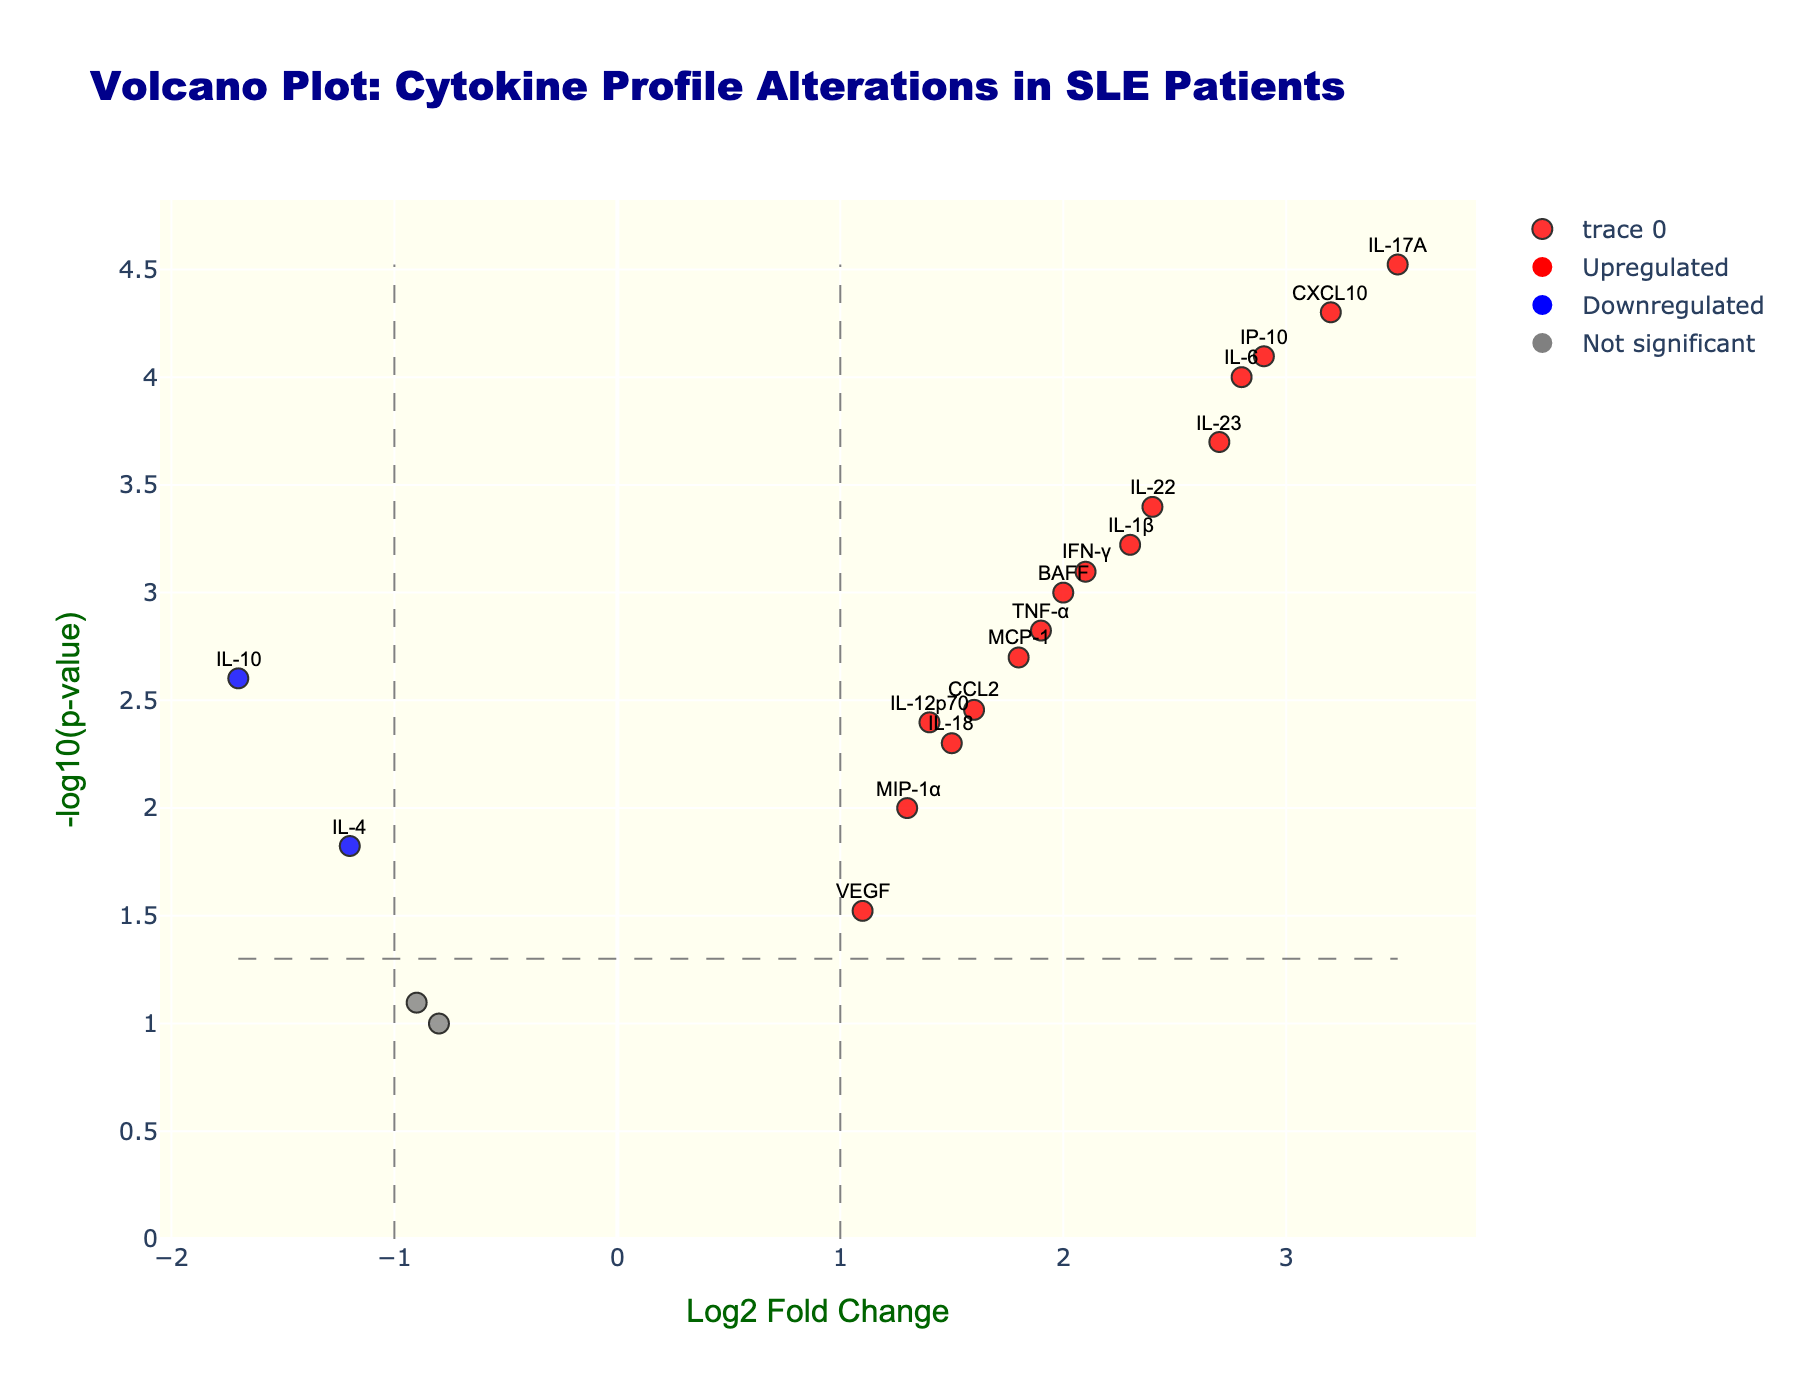How many data points have been plotted in the volcano plot? Count the number of markers plotted on the figure. The plot shows data points for each cytokine, so the number of plotted data points is equal to the number of cytokines in the provided data.
Answer: 19 What is the title of the volcano plot? The title is displayed at the top of the plot and typically summarizes what the plot represents. In this case, it is given in the figure description.
Answer: Volcano Plot: Cytokine Profile Alterations in SLE Patients Which cytokines show significant upregulation in SLE patients? Significant upregulation is indicated by red dots, where Log2FoldChange > 1 and P-value < 0.05. By identifying the red markers in the plot, we can list these cytokines.
Answer: IL-6, IL-17A, IFN-γ, IL-1β, CXCL10, IL-23, BAFF, IP-10, IL-22 Which cytokine shows the highest upregulation and what are its Log2 fold change and p-value? Look for the red marker with the highest Log2 Fold Change value. The hover text of this marker will indicate the gene name, Log2 Fold Change, and p-value.
Answer: IL-17A, Log2FC: 3.5, p-value: 0.00003 How many cytokines are significantly downregulated in SLE patients? Significant downregulation is indicated by blue dots, where Log2FoldChange < -1 and P-value < 0.05. Count the number of blue markers in the plot.
Answer: 2 What is the -log10(p-value) threshold line plotted for significance? The threshold line for significance is plotted at -log10(0.05). Calculate -log10(0.05) to get this value.
Answer: 1.301 Which cytokine has a Log2 fold change of approximately 2.9 and what is its significance level? Identify the marker near the 2.9 mark on the x-axis. By referring to the hover text on this marker, we can determine the gene name and corresponding p-value.
Answer: IP-10, p-value: 0.00008 Compare the Log2 fold change of IL-6 and TNF-α. Which cytokine shows a higher fold change and by how much? Refer to the positions of the markers for IL-6 and TNF-α on the x-axis. IL-6 is at 2.8, while TNF-α is at 1.9. Subtract the Log2 fold change of TNF-α from IL-6.
Answer: IL-6, by 0.9 What are the cytokines that do not show significant changes, and what color represents them? Non-significant changes are represented by gray dots. By identifying these markers, we can list the associated cytokines.
Answer: CCL2, IL-4, TGF-β, VEGF, IL-18, MIP-1α, IL-13 